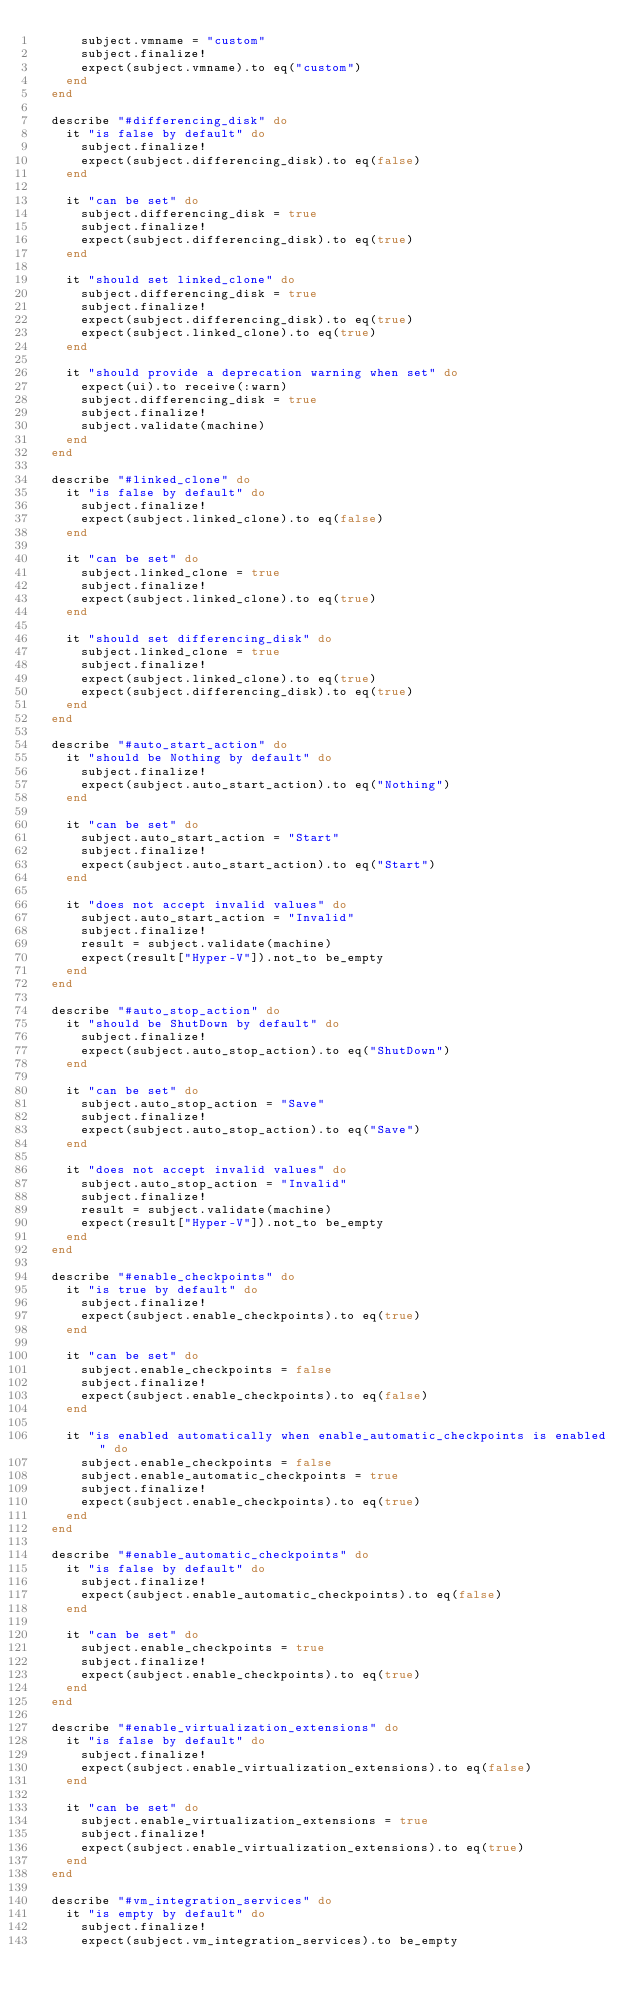<code> <loc_0><loc_0><loc_500><loc_500><_Ruby_>      subject.vmname = "custom"
      subject.finalize!
      expect(subject.vmname).to eq("custom")
    end
  end

  describe "#differencing_disk" do
    it "is false by default" do
      subject.finalize!
      expect(subject.differencing_disk).to eq(false)
    end

    it "can be set" do
      subject.differencing_disk = true
      subject.finalize!
      expect(subject.differencing_disk).to eq(true)
    end

    it "should set linked_clone" do
      subject.differencing_disk = true
      subject.finalize!
      expect(subject.differencing_disk).to eq(true)
      expect(subject.linked_clone).to eq(true)
    end

    it "should provide a deprecation warning when set" do
      expect(ui).to receive(:warn)
      subject.differencing_disk = true
      subject.finalize!
      subject.validate(machine)
    end
  end

  describe "#linked_clone" do
    it "is false by default" do
      subject.finalize!
      expect(subject.linked_clone).to eq(false)
    end

    it "can be set" do
      subject.linked_clone = true
      subject.finalize!
      expect(subject.linked_clone).to eq(true)
    end

    it "should set differencing_disk" do
      subject.linked_clone = true
      subject.finalize!
      expect(subject.linked_clone).to eq(true)
      expect(subject.differencing_disk).to eq(true)
    end
  end

  describe "#auto_start_action" do
    it "should be Nothing by default" do
      subject.finalize!
      expect(subject.auto_start_action).to eq("Nothing")
    end

    it "can be set" do
      subject.auto_start_action = "Start"
      subject.finalize!
      expect(subject.auto_start_action).to eq("Start")
    end

    it "does not accept invalid values" do
      subject.auto_start_action = "Invalid"
      subject.finalize!
      result = subject.validate(machine)
      expect(result["Hyper-V"]).not_to be_empty
    end
  end

  describe "#auto_stop_action" do
    it "should be ShutDown by default" do
      subject.finalize!
      expect(subject.auto_stop_action).to eq("ShutDown")
    end

    it "can be set" do
      subject.auto_stop_action = "Save"
      subject.finalize!
      expect(subject.auto_stop_action).to eq("Save")
    end

    it "does not accept invalid values" do
      subject.auto_stop_action = "Invalid"
      subject.finalize!
      result = subject.validate(machine)
      expect(result["Hyper-V"]).not_to be_empty
    end
  end

  describe "#enable_checkpoints" do
    it "is true by default" do
      subject.finalize!
      expect(subject.enable_checkpoints).to eq(true)
    end

    it "can be set" do
      subject.enable_checkpoints = false
      subject.finalize!
      expect(subject.enable_checkpoints).to eq(false)
    end

    it "is enabled automatically when enable_automatic_checkpoints is enabled" do
      subject.enable_checkpoints = false
      subject.enable_automatic_checkpoints = true
      subject.finalize!
      expect(subject.enable_checkpoints).to eq(true)
    end
  end

  describe "#enable_automatic_checkpoints" do
    it "is false by default" do
      subject.finalize!
      expect(subject.enable_automatic_checkpoints).to eq(false)
    end

    it "can be set" do
      subject.enable_checkpoints = true
      subject.finalize!
      expect(subject.enable_checkpoints).to eq(true)
    end
  end

  describe "#enable_virtualization_extensions" do
    it "is false by default" do
      subject.finalize!
      expect(subject.enable_virtualization_extensions).to eq(false)
    end

    it "can be set" do
      subject.enable_virtualization_extensions = true
      subject.finalize!
      expect(subject.enable_virtualization_extensions).to eq(true)
    end
  end

  describe "#vm_integration_services" do
    it "is empty by default" do
      subject.finalize!
      expect(subject.vm_integration_services).to be_empty</code> 